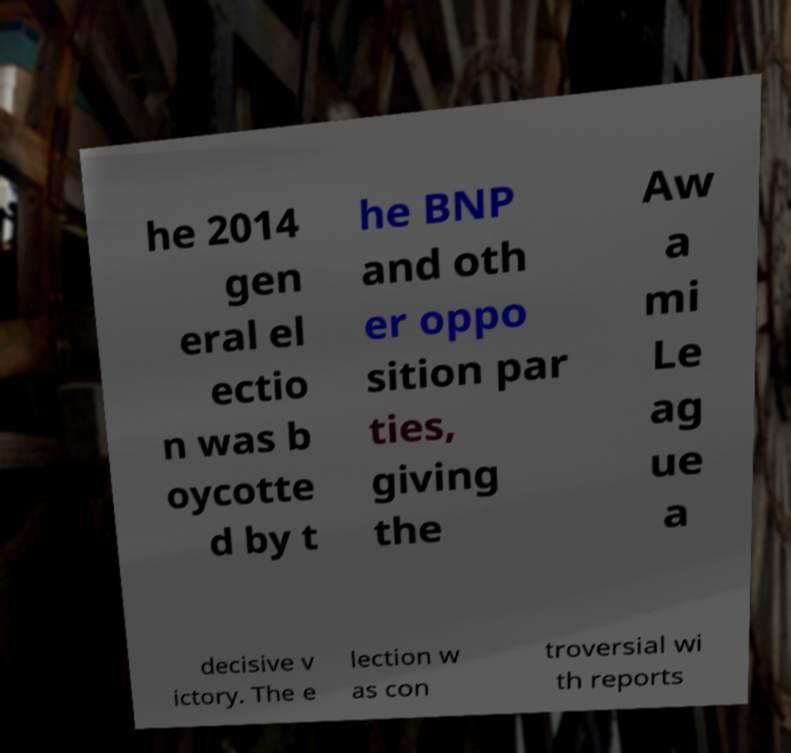For documentation purposes, I need the text within this image transcribed. Could you provide that? he 2014 gen eral el ectio n was b oycotte d by t he BNP and oth er oppo sition par ties, giving the Aw a mi Le ag ue a decisive v ictory. The e lection w as con troversial wi th reports 